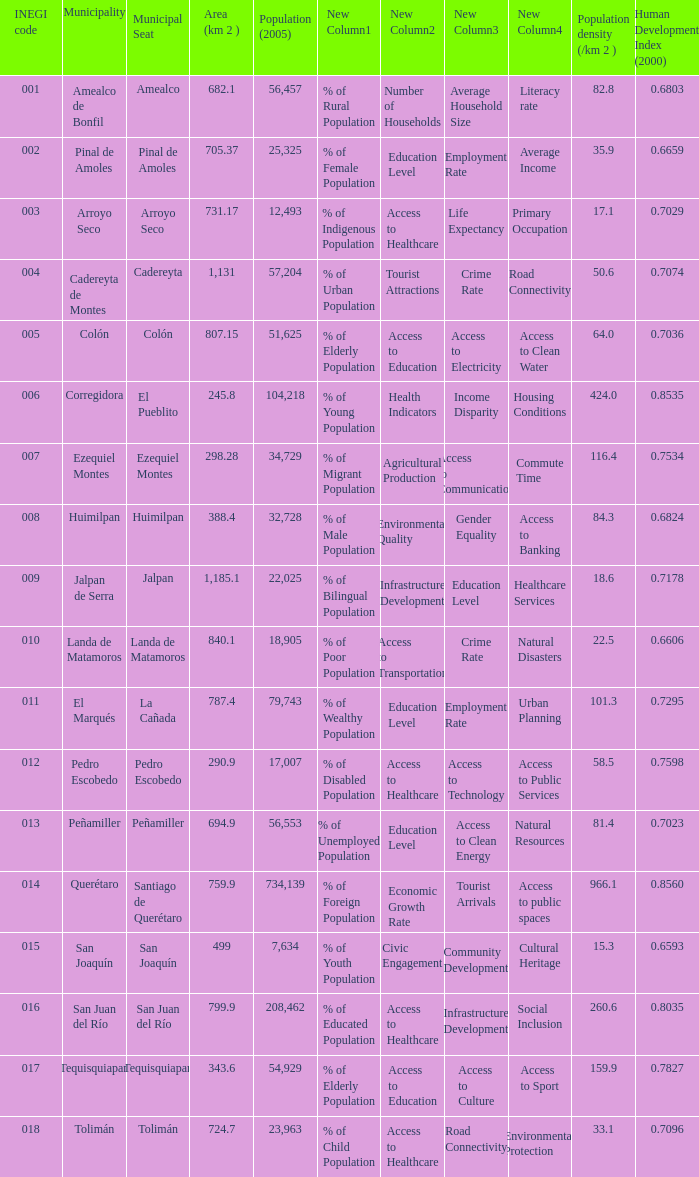WHich INEGI code has a Population density (/km 2 ) smaller than 81.4 and 0.6593 Human Development Index (2000)? 15.0. 